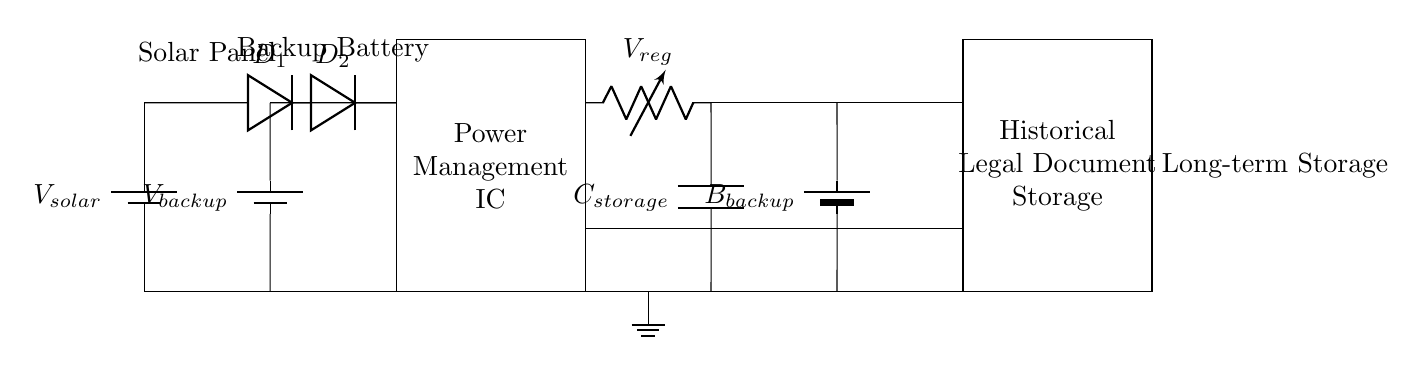What are the main power sources in the circuit? The circuit features two main power sources: a solar panel and a backup battery. These are indicated on the left side of the diagram.
Answer: solar panel, backup battery What is the role of the diodes in the circuit? The diodes direct current flow from the power sources to avoid backflow, ensuring that the power management IC receives power from the first available source.
Answer: prevent backflow What type of storage device is used for long-term data storage? The long-term data storage component is labeled as "Historical Legal Document Storage," which indicates it serves this purpose.
Answer: Historical Legal Document Storage Which component regulates the voltage in the circuit? The voltage regulator, indicated in the circuit, is responsible for maintaining a consistent voltage level for other components.
Answer: Voltage regulator How many components are involved in power selection? There are two diodes in the circuit that are specifically used for power selection from the two power sources.
Answer: two diodes Why is a capacitor included in the circuit? The capacitor is used to store energy temporarily, providing additional power to the load during brief interruptions or fluctuations in voltage.
Answer: to store energy temporarily 